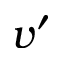<formula> <loc_0><loc_0><loc_500><loc_500>v ^ { \prime }</formula> 